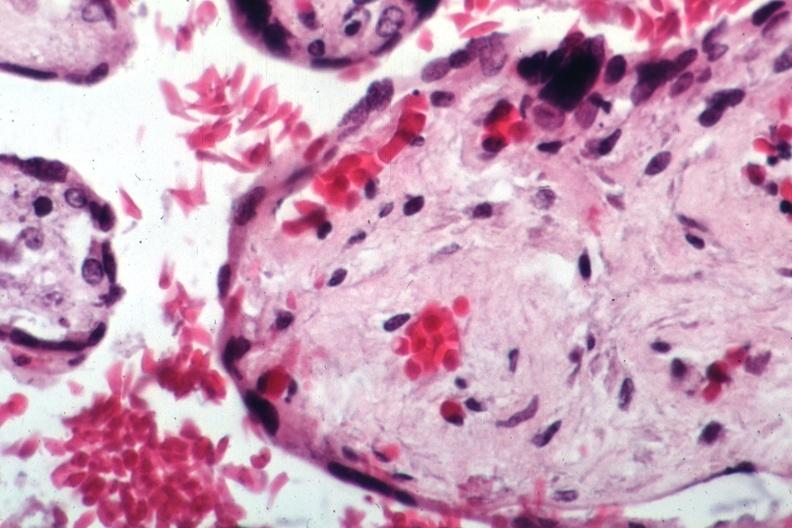s this typical thecoma with yellow foci present?
Answer the question using a single word or phrase. No 